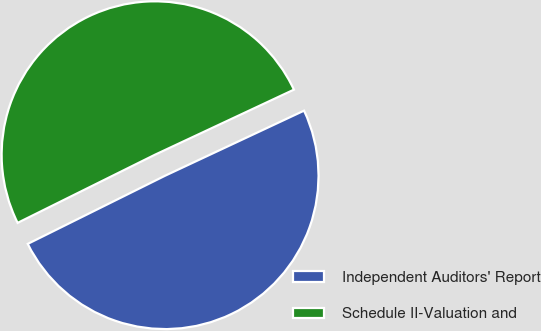<chart> <loc_0><loc_0><loc_500><loc_500><pie_chart><fcel>Independent Auditors' Report<fcel>Schedule II-Valuation and<nl><fcel>49.64%<fcel>50.36%<nl></chart> 